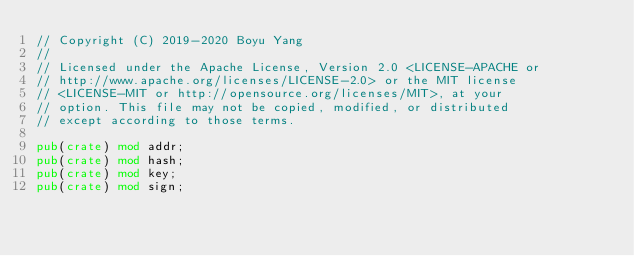Convert code to text. <code><loc_0><loc_0><loc_500><loc_500><_Rust_>// Copyright (C) 2019-2020 Boyu Yang
//
// Licensed under the Apache License, Version 2.0 <LICENSE-APACHE or
// http://www.apache.org/licenses/LICENSE-2.0> or the MIT license
// <LICENSE-MIT or http://opensource.org/licenses/MIT>, at your
// option. This file may not be copied, modified, or distributed
// except according to those terms.

pub(crate) mod addr;
pub(crate) mod hash;
pub(crate) mod key;
pub(crate) mod sign;
</code> 